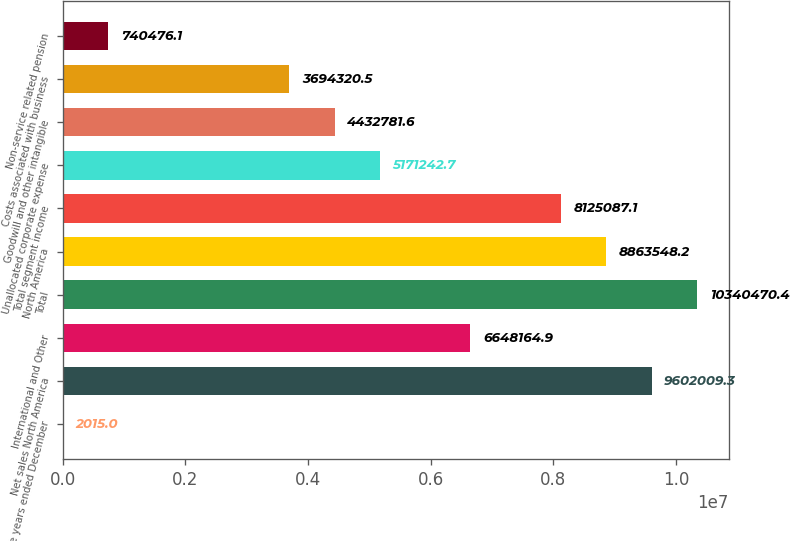Convert chart to OTSL. <chart><loc_0><loc_0><loc_500><loc_500><bar_chart><fcel>For the years ended December<fcel>Net sales North America<fcel>International and Other<fcel>Total<fcel>North America<fcel>Total segment income<fcel>Unallocated corporate expense<fcel>Goodwill and other intangible<fcel>Costs associated with business<fcel>Non-service related pension<nl><fcel>2015<fcel>9.60201e+06<fcel>6.64816e+06<fcel>1.03405e+07<fcel>8.86355e+06<fcel>8.12509e+06<fcel>5.17124e+06<fcel>4.43278e+06<fcel>3.69432e+06<fcel>740476<nl></chart> 